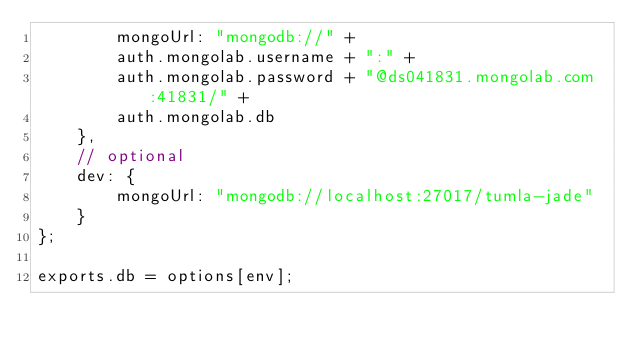<code> <loc_0><loc_0><loc_500><loc_500><_JavaScript_>        mongoUrl: "mongodb://" +
        auth.mongolab.username + ":" +
        auth.mongolab.password + "@ds041831.mongolab.com:41831/" +
        auth.mongolab.db
    },
    // optional
    dev: {
        mongoUrl: "mongodb://localhost:27017/tumla-jade"
    }
};

exports.db = options[env];</code> 